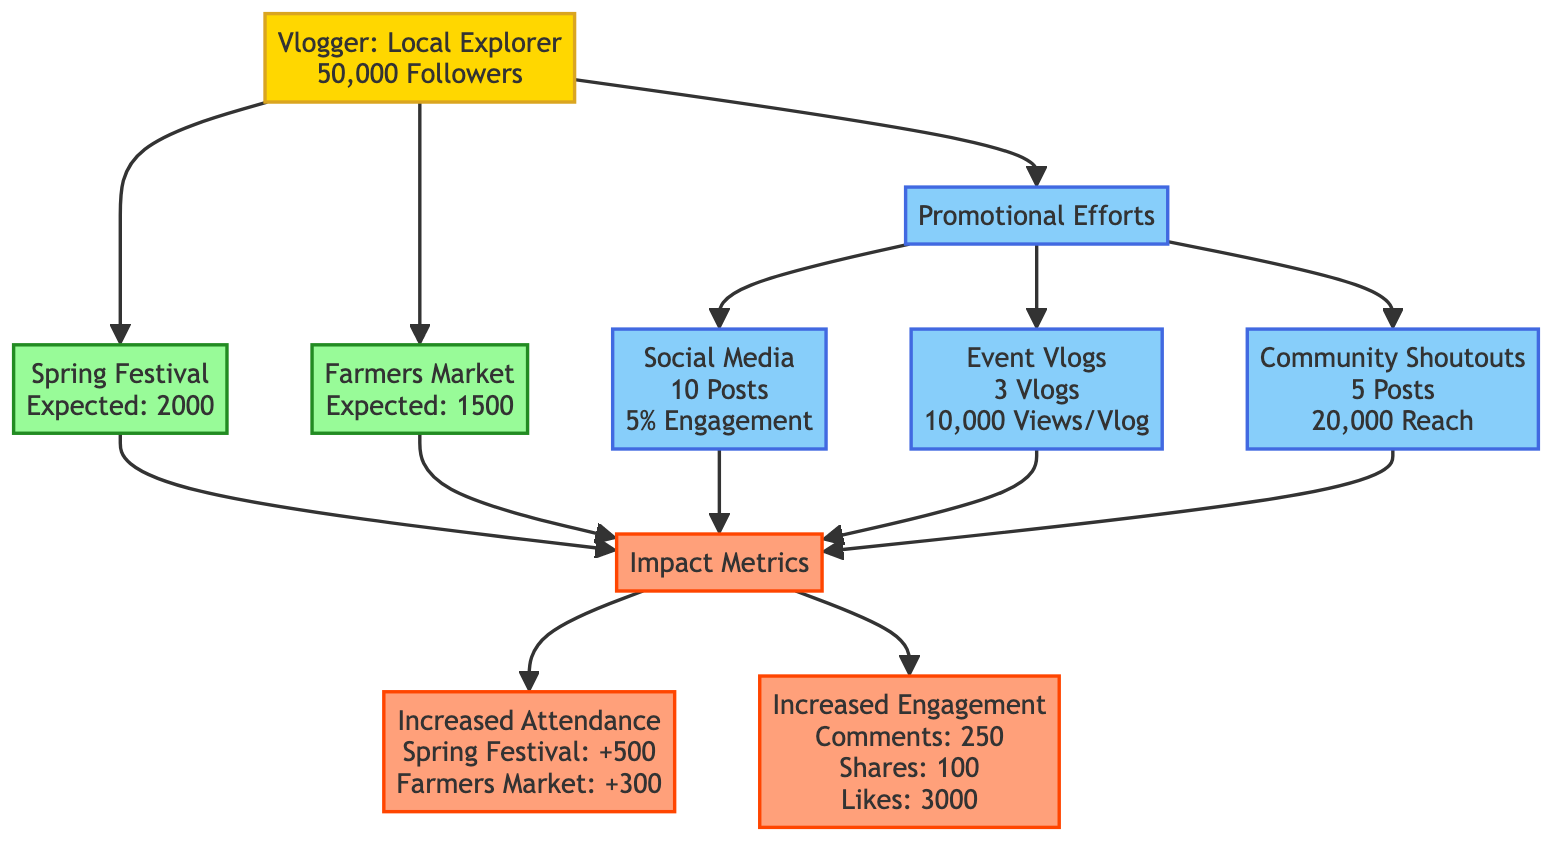What is the name of the vlogger? The diagram identifies the vlogger as "Local Explorer".
Answer: Local Explorer What is the platform used by the vlogger? The diagram states that the vlogger operates on "YouTube".
Answer: YouTube How many expected attendees are at the Spring Festival? The diagram shows the expected attendance for the Spring Festival as "2000".
Answer: 2000 How many community shoutouts did the vlogger make? According to the diagram, the vlogger made "5" community shoutouts.
Answer: 5 What is the average engagement rate for social media posts? The average engagement rate listed in the diagram for social media posts is "5%".
Answer: 5% What was the total increase in attendance for both events? The total increase can be calculated by adding the increased attendance for both events: 500 (Spring Festival) + 300 (Farmers Market) = 800.
Answer: 800 How many average views does each event vlog receive? The diagram specifies that each event vlog has an "average" of "10000" views.
Answer: 10000 What is the total reach of the community shoutouts? The diagram states the community shoutouts have a reach of "20000".
Answer: 20000 How many likes were received in total? The total likes can be understood from the diagram, which indicates "3000" likes.
Answer: 3000 